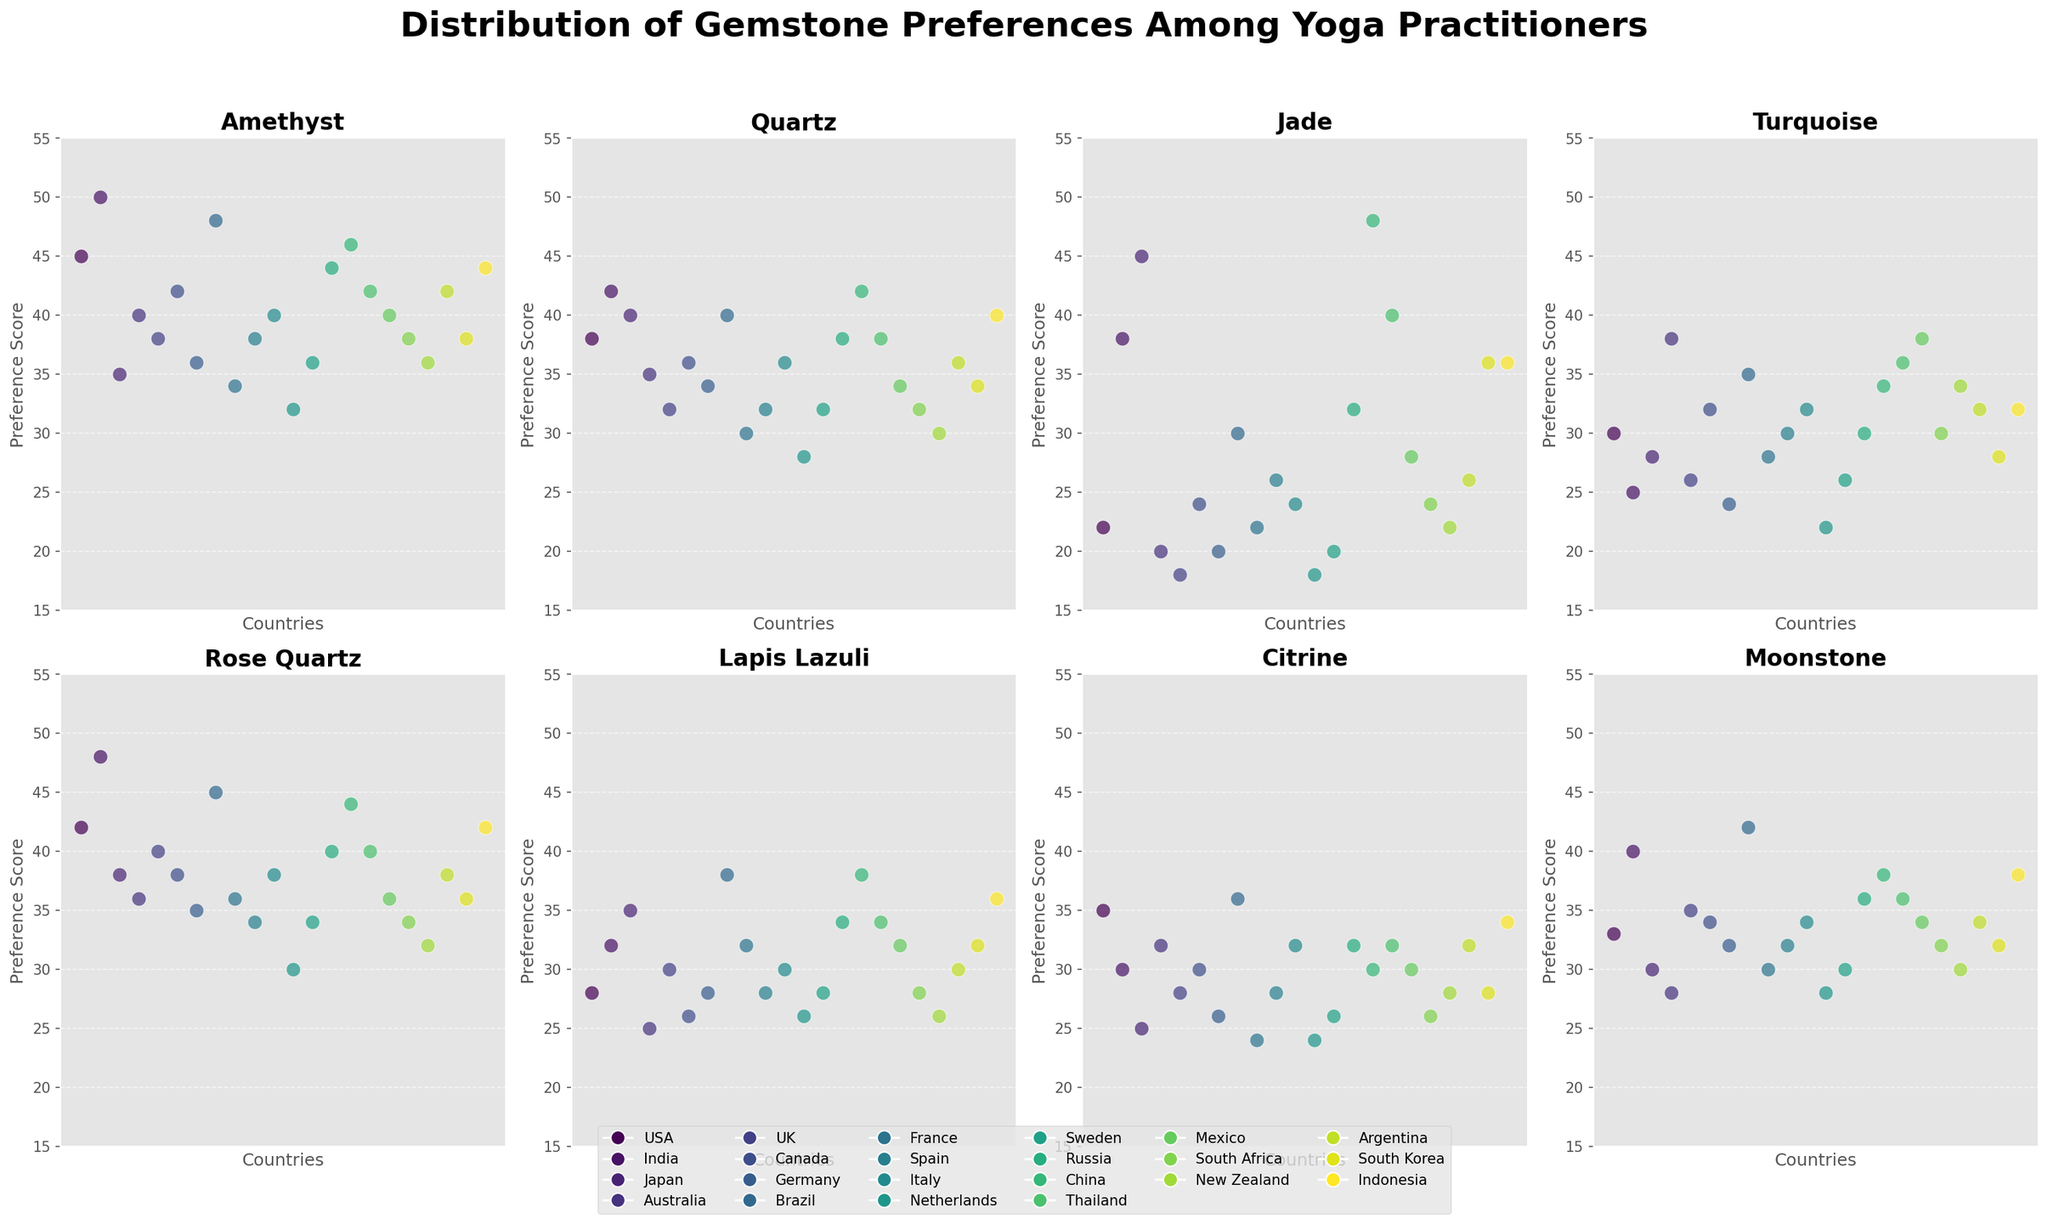Which country shows the highest preference score for Amethyst? The highest preference score for Amethyst can be found by locating the tallest data point in the Amethyst subplot. The USA has the tallest data point with a preference score of 50.
Answer: USA How does the preference for Rose Quartz in Brazil compare to that in the UK? In the Rose Quartz subplot, locate the data points corresponding to Brazil and the UK. Brazil's score is 45 while the UK's score is 40.
Answer: Brazil has a higher score What is the average preference score for Quartz among all countries? Add the preference scores for Quartz from all countries and then divide by the number of countries (20). (38 + 42 + 40 + 35 + 32 + 36 + 34 + 40 + 30 + 32 + 36 + 28 + 32 + 38 + 42 + 38 + 34 + 30 + 36 + 34 + 40) / 20 = 703 / 20 = 35.15
Answer: 35.15 Which country has the lowest preference score for Jade? In the Jade subplot, find the lowest data point, which represents the lowest preference score. The Netherlands has the lowest score of 18.
Answer: Netherlands Is the preference for Turquoise in Australia greater or lesser than in Mexico? Compare the Turquoise data points for Australia and Mexico. Australia's score is 38 and Mexico's score is 38 as well, making them equal.
Answer: Equal What is the difference in preference for Moonstone between China and Japan? In the Moonstone subplot, locate the data points for China and Japan. China has a score of 38, and Japan has a score of 30. The difference is 38 - 30 = 8.
Answer: 8 Which gemstone has the highest variability in preferences among countries? To find the gemstone with the highest variability, compare the range of preference scores in each gemstone subplot. Jade's scores range from 18 (Netherlands) to 48 (China), indicating the highest variability.
Answer: Jade How do the preferences for Lapis Lazuli in India and Thailand compare visually? Locate the Lapis Lazuli subplot and compare the data points for India and Thailand. Both countries have a score of 32, making them equal.
Answer: Equal 